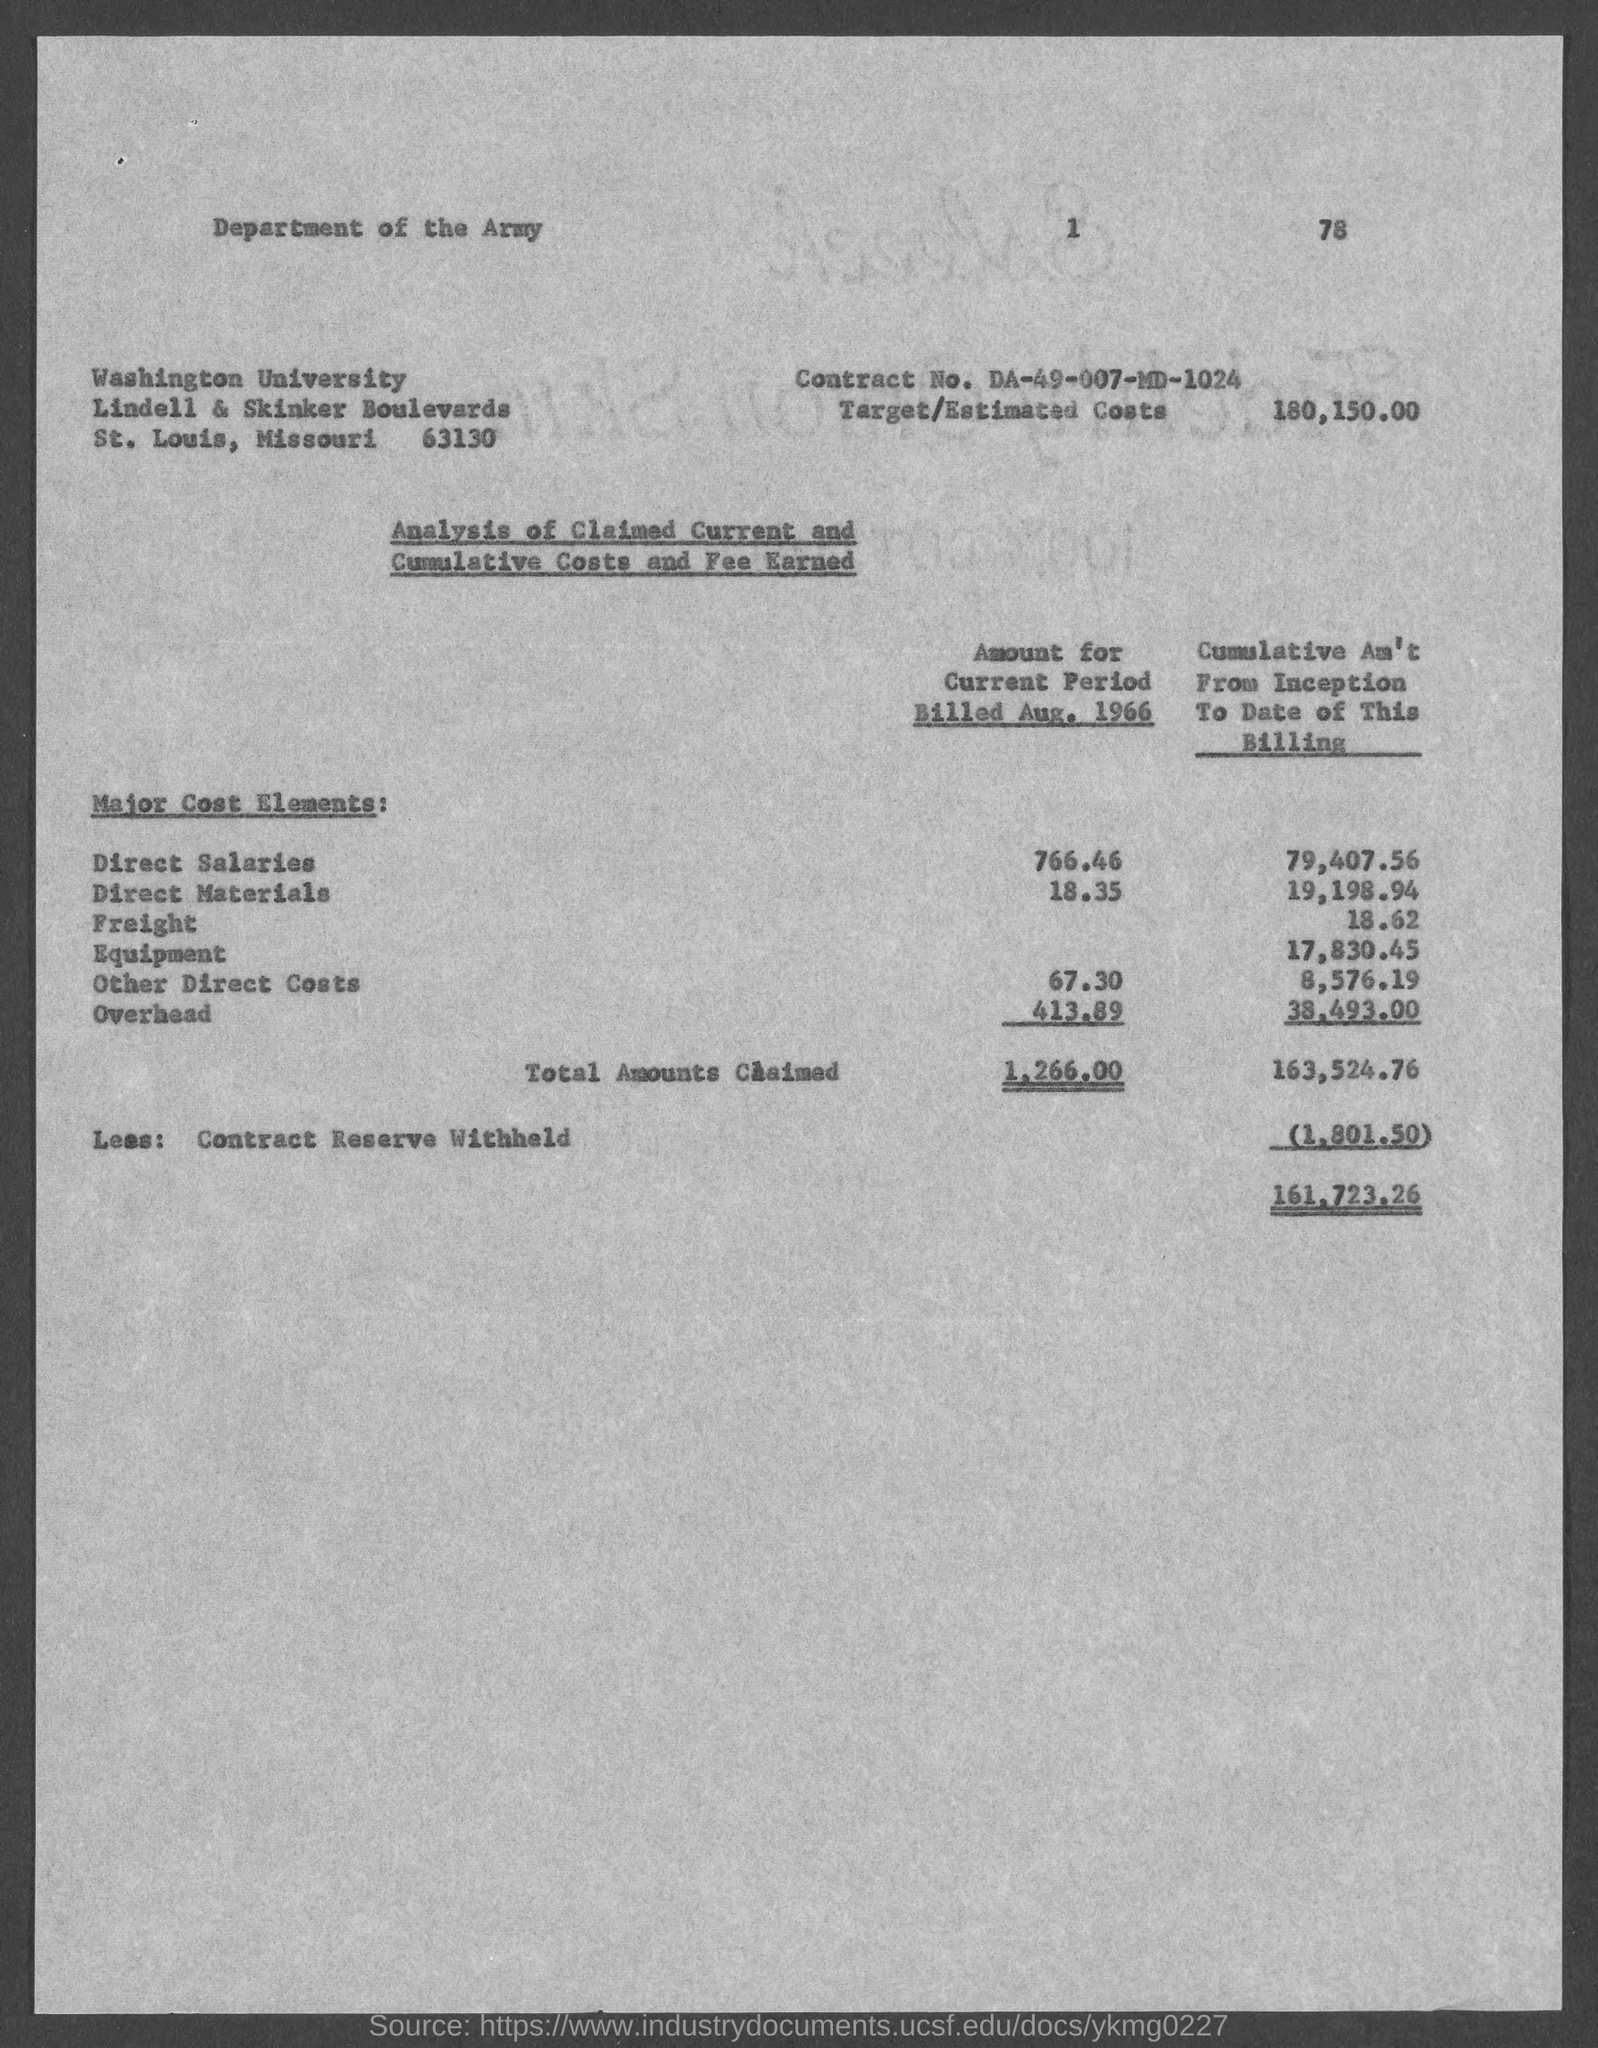Mention a couple of crucial points in this snapshot. The estimated costs for the project are 180,150. The street address of Washington University is located at Lindell & Skinker Boulevards. The contract number is DA-49-007-MD-1024. 